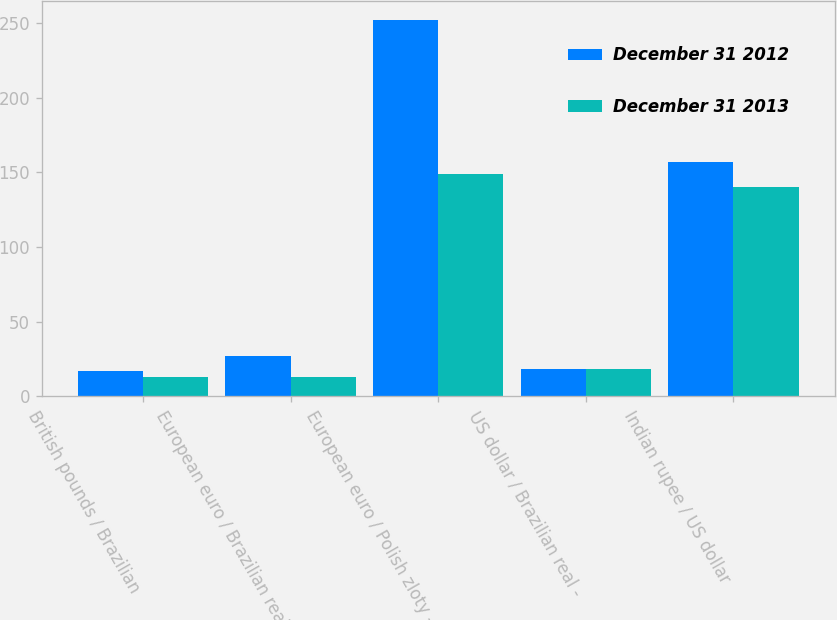Convert chart. <chart><loc_0><loc_0><loc_500><loc_500><stacked_bar_chart><ecel><fcel>British pounds / Brazilian<fcel>European euro / Brazilian real<fcel>European euro / Polish zloty -<fcel>US dollar / Brazilian real -<fcel>Indian rupee / US dollar<nl><fcel>December 31 2012<fcel>17<fcel>27<fcel>252<fcel>18<fcel>157<nl><fcel>December 31 2013<fcel>13<fcel>13<fcel>149<fcel>18<fcel>140<nl></chart> 